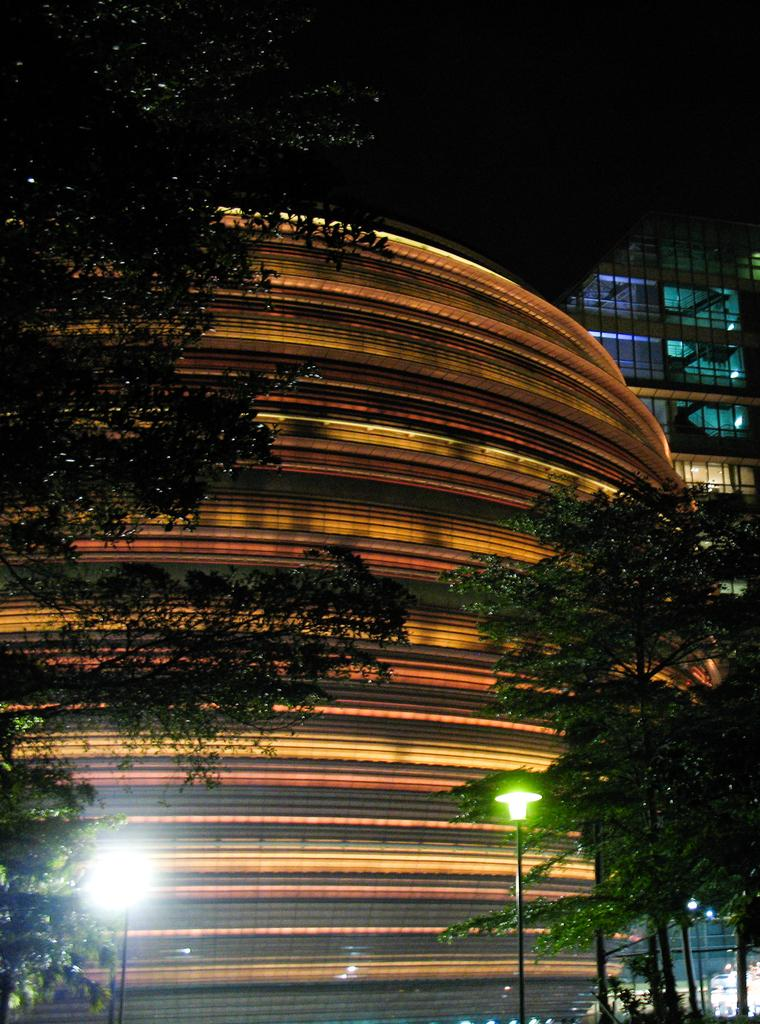What type of structures can be seen in the image? There are buildings in the image. What is located in the foreground of the image? There are lights and trees in the foreground of the image. What type of machine can be seen operating in the hole in the image? There is no machine or hole present in the image; it features buildings, lights, and trees. 